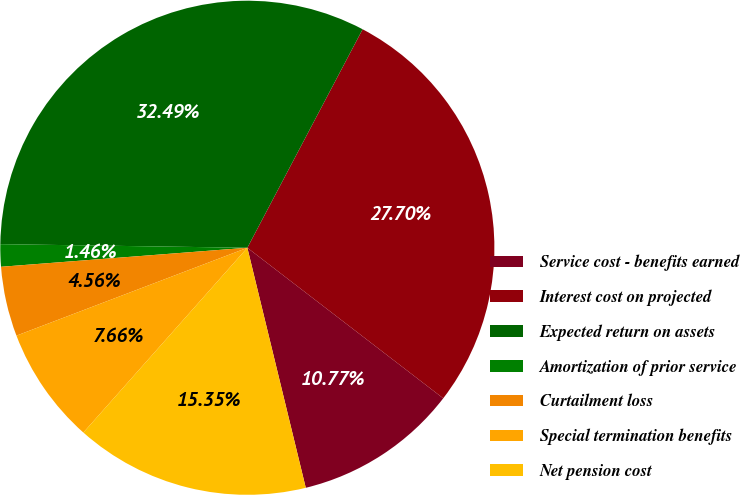Convert chart. <chart><loc_0><loc_0><loc_500><loc_500><pie_chart><fcel>Service cost - benefits earned<fcel>Interest cost on projected<fcel>Expected return on assets<fcel>Amortization of prior service<fcel>Curtailment loss<fcel>Special termination benefits<fcel>Net pension cost<nl><fcel>10.77%<fcel>27.7%<fcel>32.49%<fcel>1.46%<fcel>4.56%<fcel>7.66%<fcel>15.35%<nl></chart> 